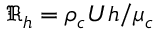<formula> <loc_0><loc_0><loc_500><loc_500>\Re _ { h } = \rho _ { c } U h / \mu _ { c }</formula> 